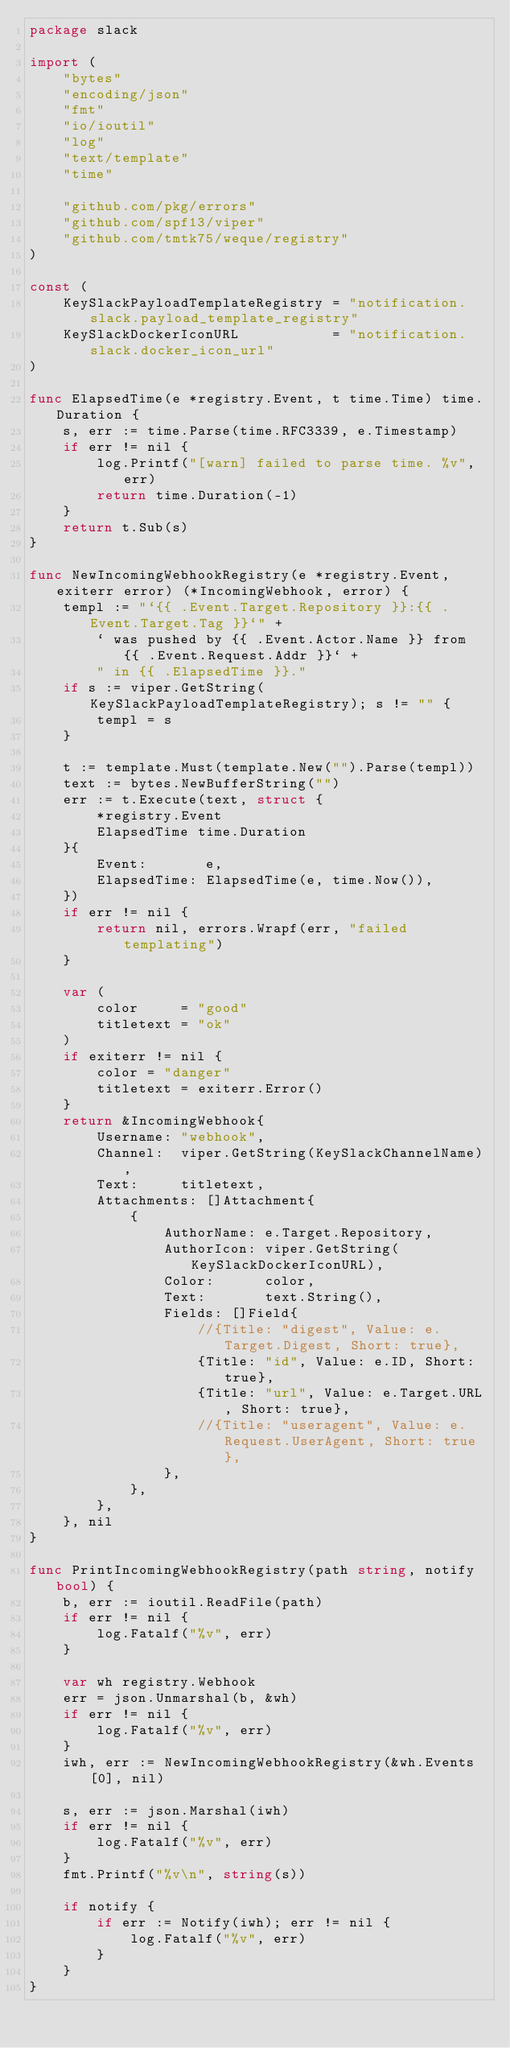Convert code to text. <code><loc_0><loc_0><loc_500><loc_500><_Go_>package slack

import (
	"bytes"
	"encoding/json"
	"fmt"
	"io/ioutil"
	"log"
	"text/template"
	"time"

	"github.com/pkg/errors"
	"github.com/spf13/viper"
	"github.com/tmtk75/weque/registry"
)

const (
	KeySlackPayloadTemplateRegistry = "notification.slack.payload_template_registry"
	KeySlackDockerIconURL           = "notification.slack.docker_icon_url"
)

func ElapsedTime(e *registry.Event, t time.Time) time.Duration {
	s, err := time.Parse(time.RFC3339, e.Timestamp)
	if err != nil {
		log.Printf("[warn] failed to parse time. %v", err)
		return time.Duration(-1)
	}
	return t.Sub(s)
}

func NewIncomingWebhookRegistry(e *registry.Event, exiterr error) (*IncomingWebhook, error) {
	templ := "`{{ .Event.Target.Repository }}:{{ .Event.Target.Tag }}`" +
		` was pushed by {{ .Event.Actor.Name }} from {{ .Event.Request.Addr }}` +
		" in {{ .ElapsedTime }}."
	if s := viper.GetString(KeySlackPayloadTemplateRegistry); s != "" {
		templ = s
	}

	t := template.Must(template.New("").Parse(templ))
	text := bytes.NewBufferString("")
	err := t.Execute(text, struct {
		*registry.Event
		ElapsedTime time.Duration
	}{
		Event:       e,
		ElapsedTime: ElapsedTime(e, time.Now()),
	})
	if err != nil {
		return nil, errors.Wrapf(err, "failed templating")
	}

	var (
		color     = "good"
		titletext = "ok"
	)
	if exiterr != nil {
		color = "danger"
		titletext = exiterr.Error()
	}
	return &IncomingWebhook{
		Username: "webhook",
		Channel:  viper.GetString(KeySlackChannelName),
		Text:     titletext,
		Attachments: []Attachment{
			{
				AuthorName: e.Target.Repository,
				AuthorIcon: viper.GetString(KeySlackDockerIconURL),
				Color:      color,
				Text:       text.String(),
				Fields: []Field{
					//{Title: "digest", Value: e.Target.Digest, Short: true},
					{Title: "id", Value: e.ID, Short: true},
					{Title: "url", Value: e.Target.URL, Short: true},
					//{Title: "useragent", Value: e.Request.UserAgent, Short: true},
				},
			},
		},
	}, nil
}

func PrintIncomingWebhookRegistry(path string, notify bool) {
	b, err := ioutil.ReadFile(path)
	if err != nil {
		log.Fatalf("%v", err)
	}

	var wh registry.Webhook
	err = json.Unmarshal(b, &wh)
	if err != nil {
		log.Fatalf("%v", err)
	}
	iwh, err := NewIncomingWebhookRegistry(&wh.Events[0], nil)

	s, err := json.Marshal(iwh)
	if err != nil {
		log.Fatalf("%v", err)
	}
	fmt.Printf("%v\n", string(s))

	if notify {
		if err := Notify(iwh); err != nil {
			log.Fatalf("%v", err)
		}
	}
}
</code> 